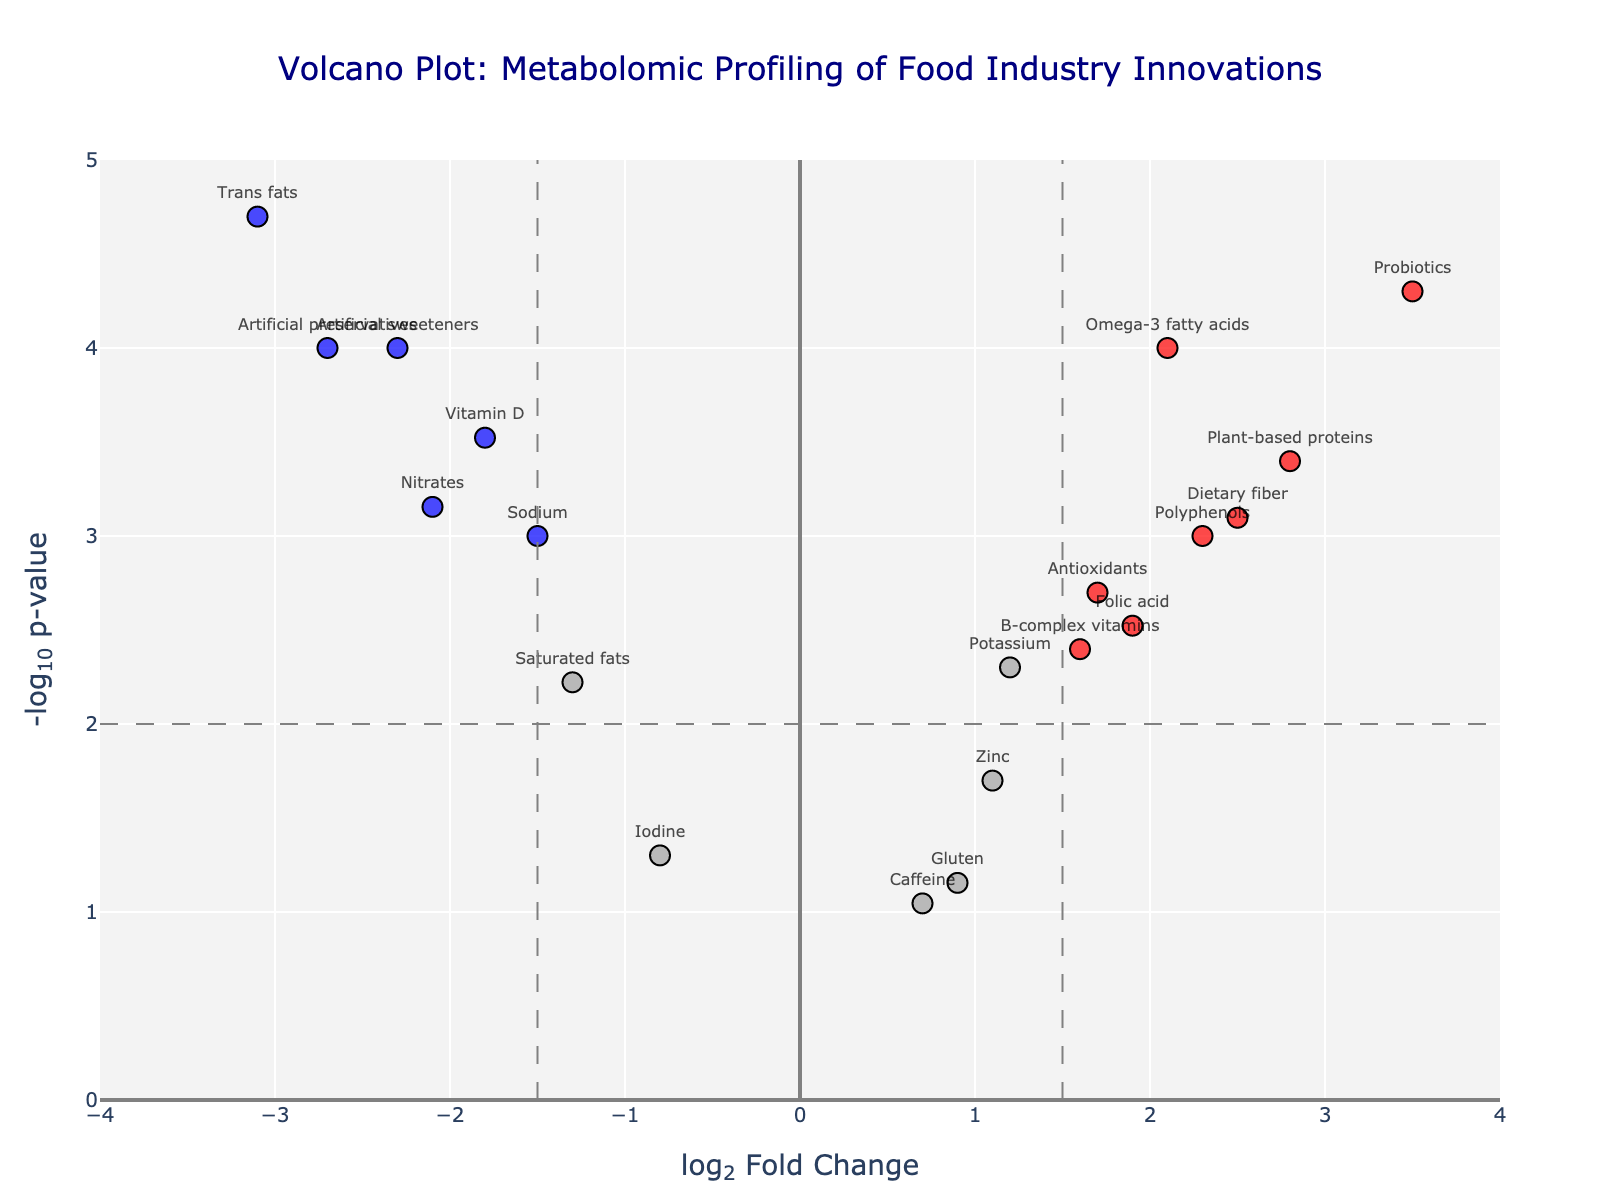What's the title of the plot? The title is displayed at the top of the plot and generally summarizes the main topic being visualized.
Answer: "Volcano Plot: Metabolomic Profiling of Food Industry Innovations" Which compound has the highest log2 fold change? To determine the highest log2 fold change, look for the compound that is farthest to the right on the x-axis.
Answer: Probiotics How many compounds have a significant positive change (log2 fold change > 1.5 and p-value < 0.01)? Identify compounds that meet both criteria: log2 fold change greater than 1.5 and -log10(p-value) above 2. These compounds are marked in red.
Answer: 4 compounds (Omega-3 fatty acids, Probiotics, Plant-based proteins, Polyphenols) Which compound has the lowest p-value? To find the lowest p-value, look for the compound that is highest on the y-axis, as -log10(p-value) is plotted vertically.
Answer: Trans fats What's the log2 fold change value of Artificial sweeteners? Locate Artificial sweeteners on the plot and read the corresponding x-coordinate for its log2 fold change.
Answer: -2.3 Between Sodium and Zinc, which has a more significant p-value? Compare the y-coordinates of Sodium and Zinc to see which one is higher, indicating a more significant p-value.
Answer: Sodium How many compounds are neither significantly positively nor significantly negatively changed (log2 fold change between -1.5 and 1.5 and p-value > 0.01)? Count the compounds within the neutral zone: x-values between -1.5 and 1.5 and y-values below 2.
Answer: 6 compounds (Gluten, Caffeine, Potassium, Zinc, Iodine, Folic acid) Name the compounds that have a significant negative change (log2 fold change < -1.5 and p-value < 0.01). Identify the compounds that meet both criteria: log2 fold change less than -1.5 and -log10(p-value) above 2. These compounds are marked in blue.
Answer: Artificial sweeteners, Trans fats, Artificial preservatives What's the range of log2 fold change for the presented compounds? Determine the minimum and maximum log2 fold change values by examining the dataset or the plot’s x-axis limits.
Answer: -3.1 to 3.5 